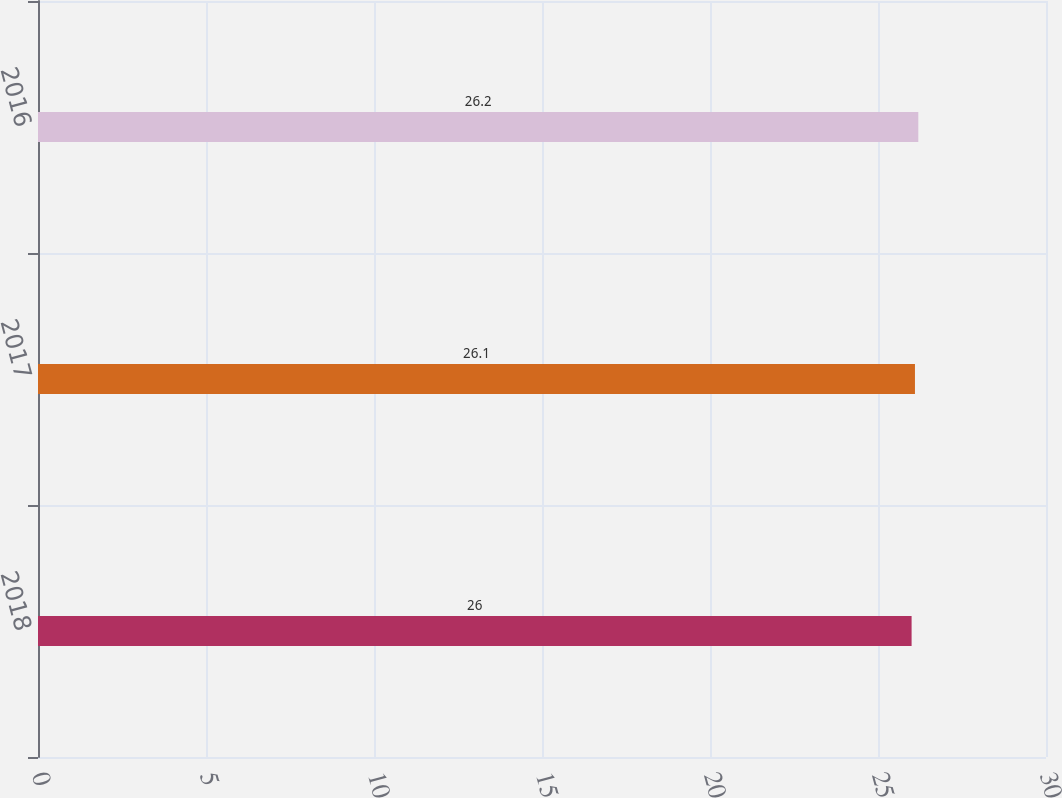<chart> <loc_0><loc_0><loc_500><loc_500><bar_chart><fcel>2018<fcel>2017<fcel>2016<nl><fcel>26<fcel>26.1<fcel>26.2<nl></chart> 